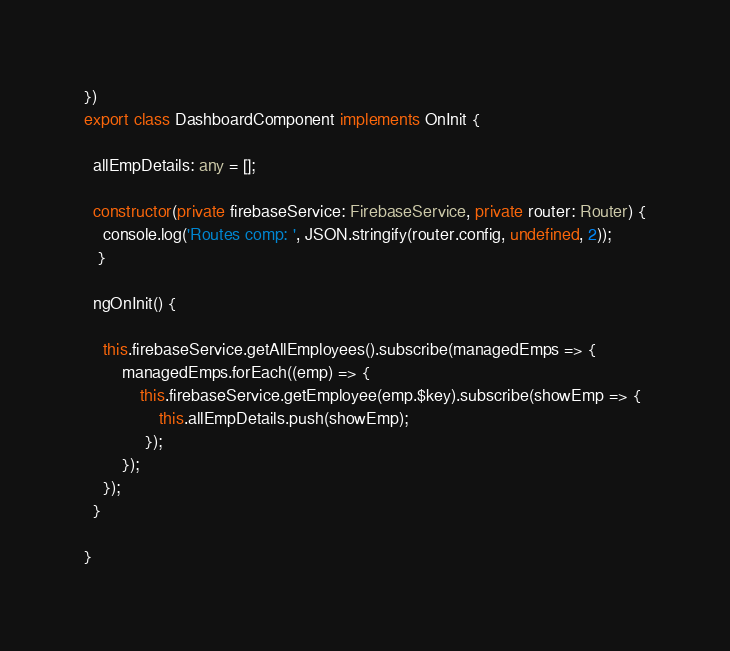<code> <loc_0><loc_0><loc_500><loc_500><_TypeScript_>})
export class DashboardComponent implements OnInit {

  allEmpDetails: any = [];
  
  constructor(private firebaseService: FirebaseService, private router: Router) {
  	console.log('Routes comp: ', JSON.stringify(router.config, undefined, 2));
   }

  ngOnInit() {
  	
  	this.firebaseService.getAllEmployees().subscribe(managedEmps => {
 		managedEmps.forEach((emp) => {
	  		this.firebaseService.getEmployee(emp.$key).subscribe(showEmp => {
			 	this.allEmpDetails.push(showEmp);
			 });
  		});
	});
  }

}
</code> 